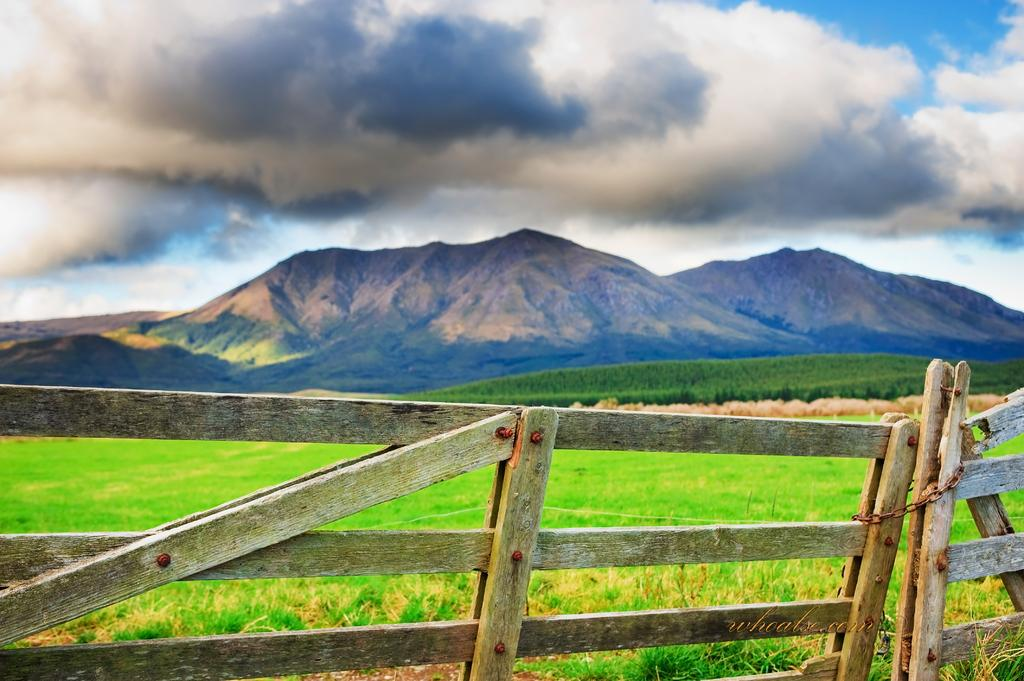What type of barrier can be seen in the image? There is a wooden fence in the image. What type of vegetation is visible in the background of the image? There is grass and plants in the background of the image. What type of natural landform is visible in the background of the image? There are mountains in the background of the image. What part of the natural environment is visible in the background of the image? The sky is visible in the background of the image. How many boats can be seen in the image? There are no boats present in the image. What color are the toes of the person in the image? There is no person present in the image, so there are no toes to describe. 